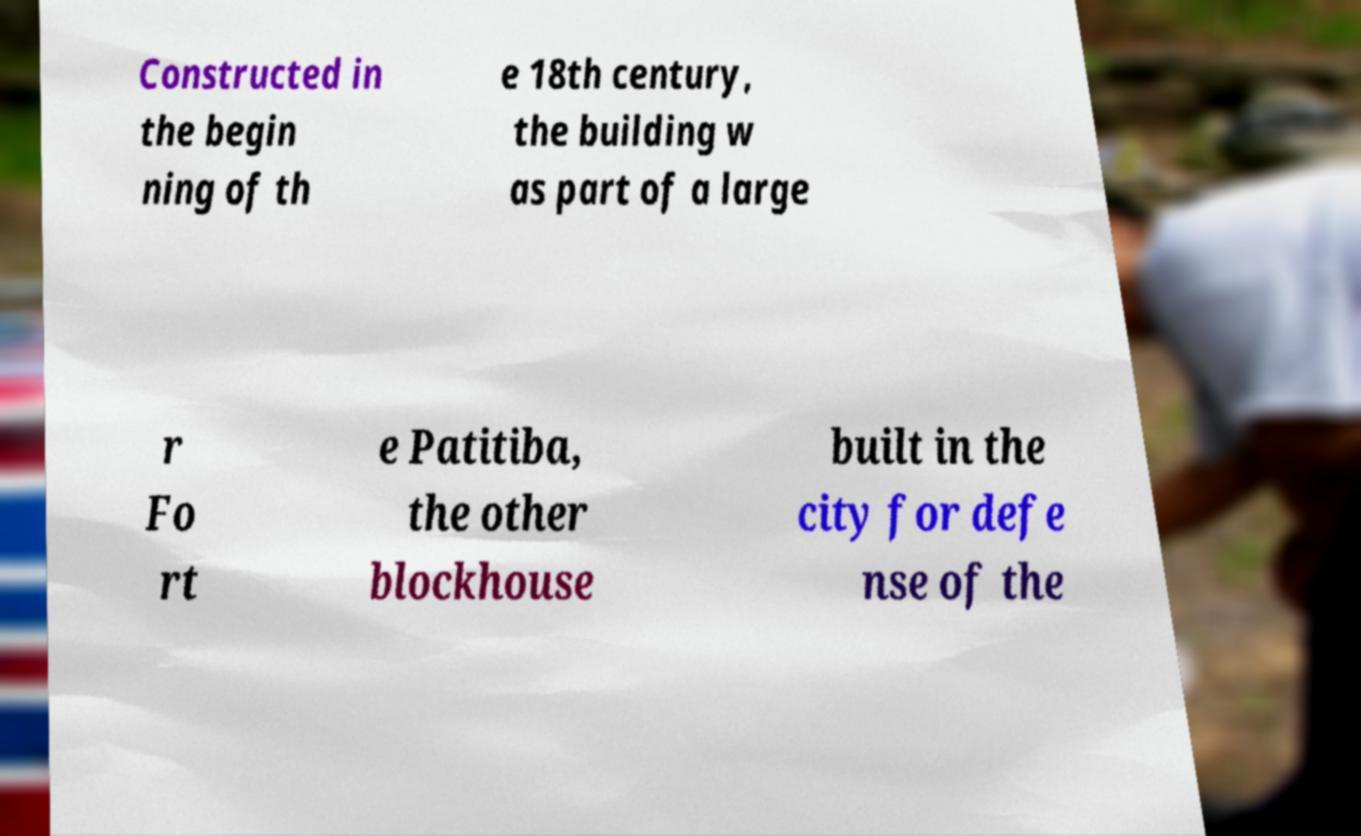What messages or text are displayed in this image? I need them in a readable, typed format. Constructed in the begin ning of th e 18th century, the building w as part of a large r Fo rt e Patitiba, the other blockhouse built in the city for defe nse of the 